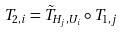Convert formula to latex. <formula><loc_0><loc_0><loc_500><loc_500>T _ { 2 , i } = \tilde { T } _ { H _ { j } , U _ { i } } \circ T _ { 1 , j }</formula> 